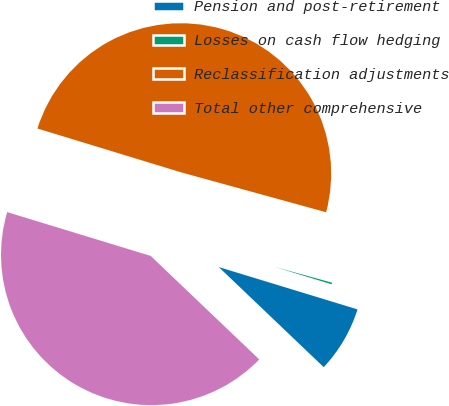Convert chart. <chart><loc_0><loc_0><loc_500><loc_500><pie_chart><fcel>Pension and post-retirement<fcel>Losses on cash flow hedging<fcel>Reclassification adjustments<fcel>Total other comprehensive<nl><fcel>7.41%<fcel>0.44%<fcel>49.56%<fcel>42.59%<nl></chart> 